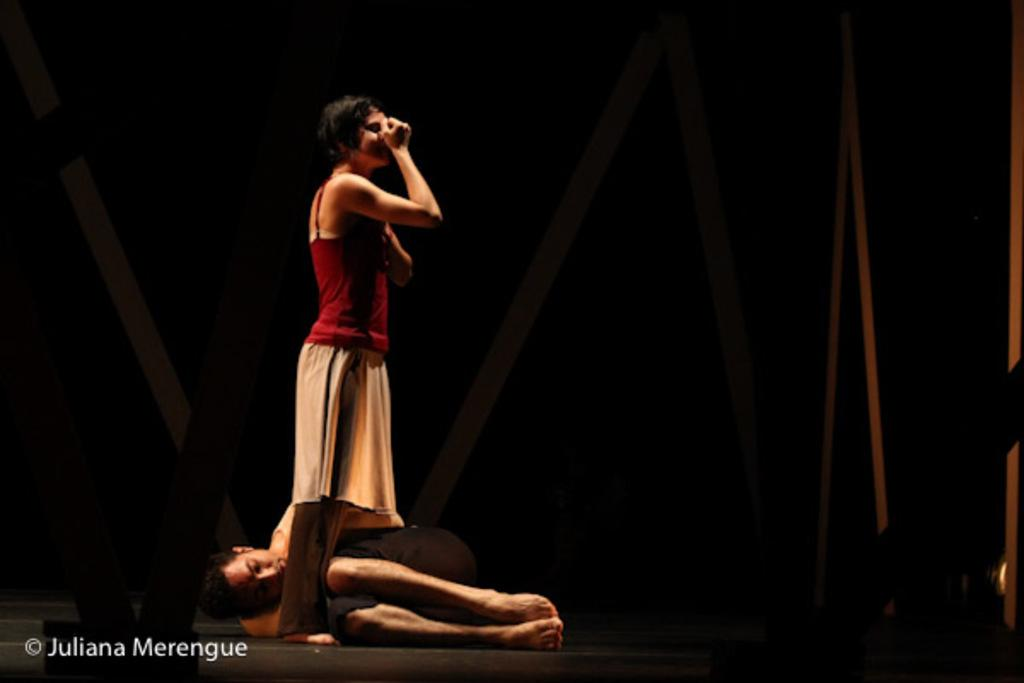What is the woman doing in the image? The woman is standing on a stage in the image. What is the man doing in the image? The man is sleeping on the floor in the image. What color is the wren's memory in the image? There is no wren present in the image, and therefore no memory to describe. 